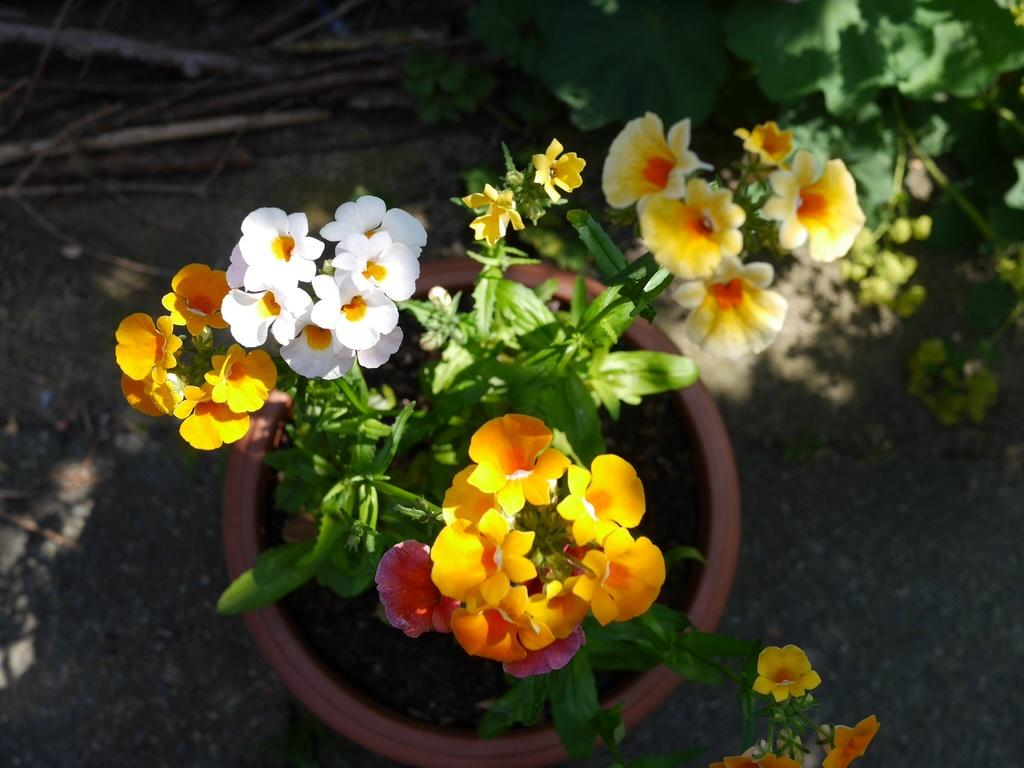What types of flowers are visible in the image? There are white and yellow flowers in the image. Where are the flowers located? The flowers are on a plant. How is the plant contained in the image? The plant is in a flower pot. Can you describe the background of the image? The background of the image is slightly blurred. What type of attack is being carried out by the plantation in the image? There is no plantation present in the image, and therefore no attack can be observed. 